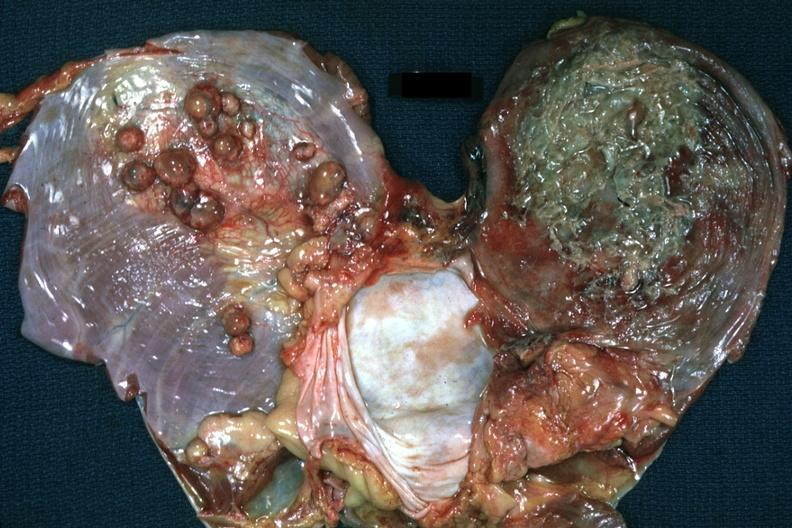what is present?
Answer the question using a single word or phrase. Muscle 